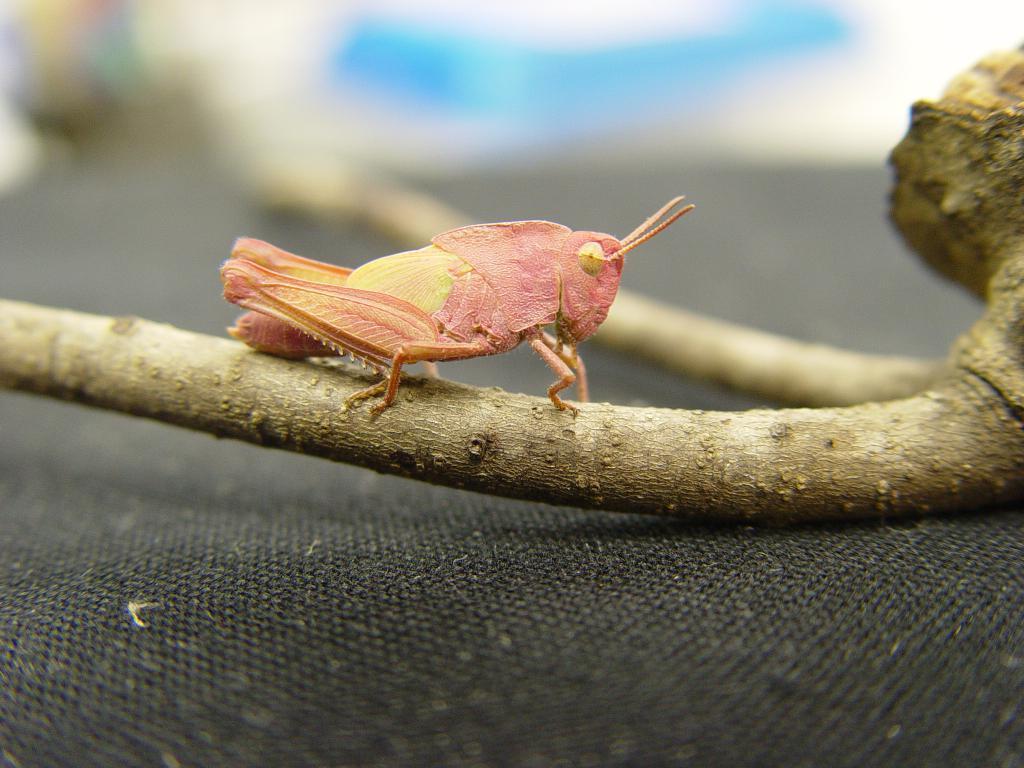Could you give a brief overview of what you see in this image? In the middle of the image there is a grasshopper on the stem of a plant on the black surface. In this image the background is blurred. At the bottom of the image there is a black surface. 